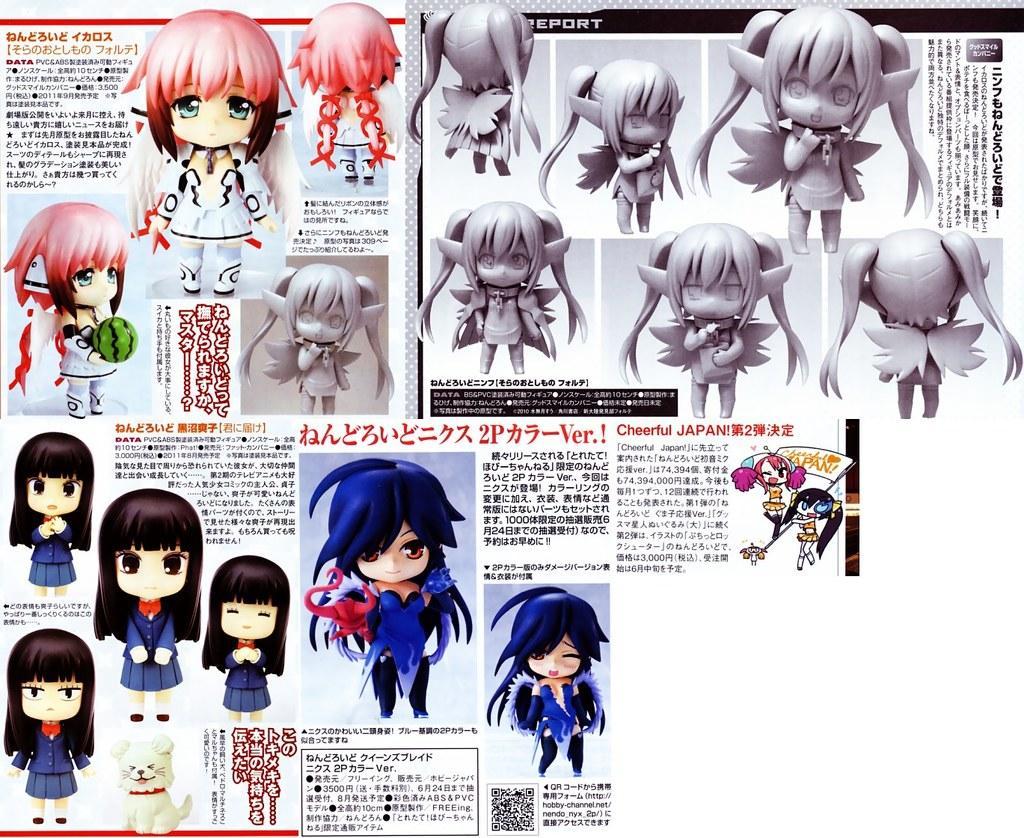Can you describe this image briefly? This is a picture of a poster, where there are paragraphs and toys. 